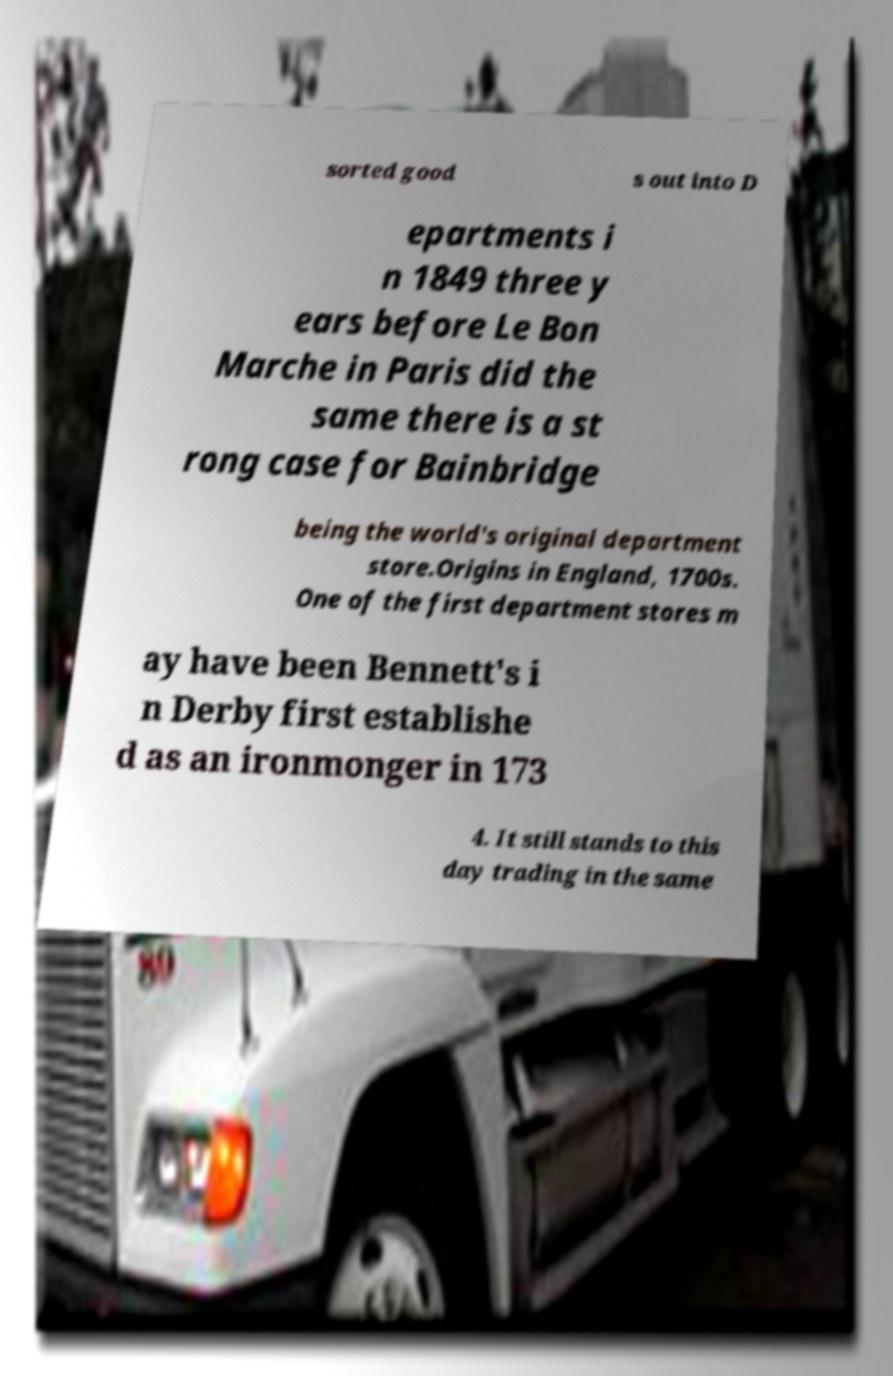There's text embedded in this image that I need extracted. Can you transcribe it verbatim? sorted good s out into D epartments i n 1849 three y ears before Le Bon Marche in Paris did the same there is a st rong case for Bainbridge being the world's original department store.Origins in England, 1700s. One of the first department stores m ay have been Bennett's i n Derby first establishe d as an ironmonger in 173 4. It still stands to this day trading in the same 